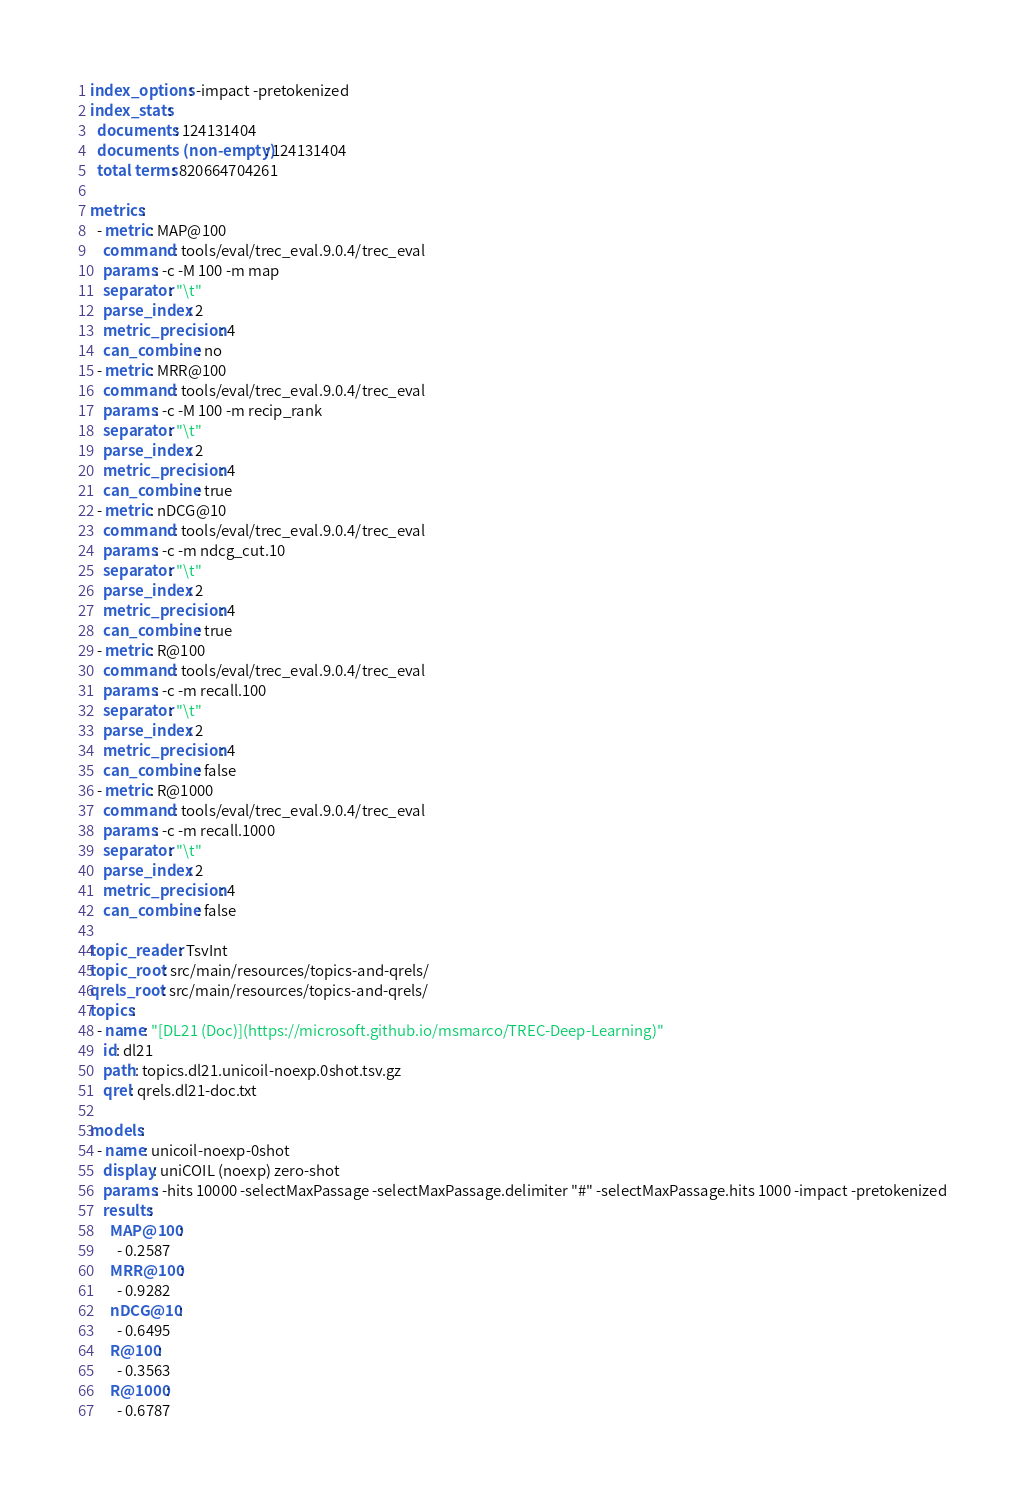Convert code to text. <code><loc_0><loc_0><loc_500><loc_500><_YAML_>index_options: -impact -pretokenized
index_stats:
  documents: 124131404
  documents (non-empty): 124131404
  total terms: 820664704261

metrics:
  - metric: MAP@100
    command: tools/eval/trec_eval.9.0.4/trec_eval
    params: -c -M 100 -m map
    separator: "\t"
    parse_index: 2
    metric_precision: 4
    can_combine: no
  - metric: MRR@100
    command: tools/eval/trec_eval.9.0.4/trec_eval
    params: -c -M 100 -m recip_rank
    separator: "\t"
    parse_index: 2
    metric_precision: 4
    can_combine: true
  - metric: nDCG@10
    command: tools/eval/trec_eval.9.0.4/trec_eval
    params: -c -m ndcg_cut.10
    separator: "\t"
    parse_index: 2
    metric_precision: 4
    can_combine: true
  - metric: R@100
    command: tools/eval/trec_eval.9.0.4/trec_eval
    params: -c -m recall.100
    separator: "\t"
    parse_index: 2
    metric_precision: 4
    can_combine: false
  - metric: R@1000
    command: tools/eval/trec_eval.9.0.4/trec_eval
    params: -c -m recall.1000
    separator: "\t"
    parse_index: 2
    metric_precision: 4
    can_combine: false

topic_reader: TsvInt
topic_root: src/main/resources/topics-and-qrels/
qrels_root: src/main/resources/topics-and-qrels/
topics:
  - name: "[DL21 (Doc)](https://microsoft.github.io/msmarco/TREC-Deep-Learning)"
    id: dl21
    path: topics.dl21.unicoil-noexp.0shot.tsv.gz
    qrel: qrels.dl21-doc.txt

models:
  - name: unicoil-noexp-0shot
    display: uniCOIL (noexp) zero-shot
    params: -hits 10000 -selectMaxPassage -selectMaxPassage.delimiter "#" -selectMaxPassage.hits 1000 -impact -pretokenized
    results:
      MAP@100:
        - 0.2587
      MRR@100:
        - 0.9282
      nDCG@10:
        - 0.6495
      R@100:
        - 0.3563
      R@1000:
        - 0.6787</code> 